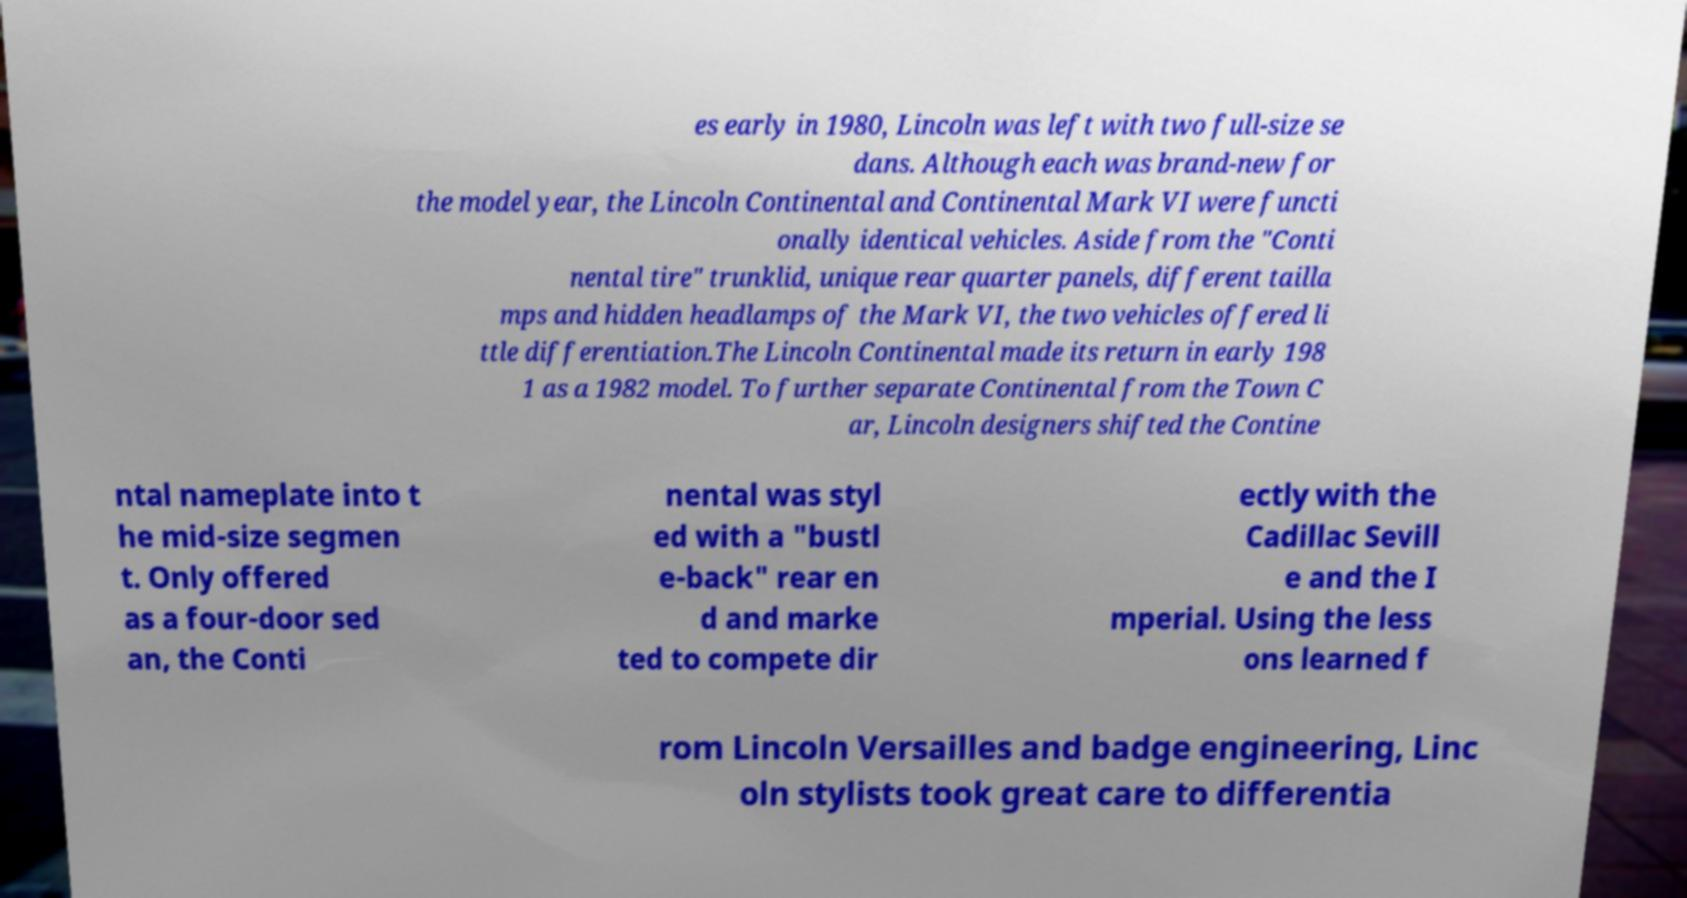Could you extract and type out the text from this image? es early in 1980, Lincoln was left with two full-size se dans. Although each was brand-new for the model year, the Lincoln Continental and Continental Mark VI were functi onally identical vehicles. Aside from the "Conti nental tire" trunklid, unique rear quarter panels, different tailla mps and hidden headlamps of the Mark VI, the two vehicles offered li ttle differentiation.The Lincoln Continental made its return in early 198 1 as a 1982 model. To further separate Continental from the Town C ar, Lincoln designers shifted the Contine ntal nameplate into t he mid-size segmen t. Only offered as a four-door sed an, the Conti nental was styl ed with a "bustl e-back" rear en d and marke ted to compete dir ectly with the Cadillac Sevill e and the I mperial. Using the less ons learned f rom Lincoln Versailles and badge engineering, Linc oln stylists took great care to differentia 